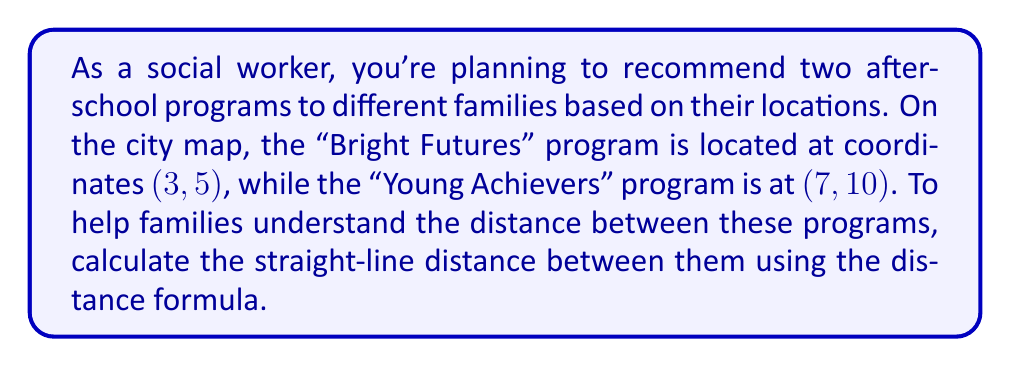Give your solution to this math problem. To solve this problem, we'll use the distance formula derived from the Pythagorean theorem. The distance formula for two points $(x_1, y_1)$ and $(x_2, y_2)$ is:

$$d = \sqrt{(x_2 - x_1)^2 + (y_2 - y_1)^2}$$

Let's identify our points:
- "Bright Futures": $(x_1, y_1) = (3, 5)$
- "Young Achievers": $(x_2, y_2) = (7, 10)$

Now, let's substitute these values into the formula:

$$\begin{align*}
d &= \sqrt{(7 - 3)^2 + (10 - 5)^2} \\
&= \sqrt{4^2 + 5^2} \\
&= \sqrt{16 + 25} \\
&= \sqrt{41} \\
&\approx 6.40 \text{ units}
\end{align*}$$

The unit of measurement depends on the scale of the city map. If the map uses a scale where 1 unit = 1 mile, then the distance would be approximately 6.40 miles.

[asy]
unitsize(1cm);
draw((-1,-1)--(9,12), gray);
dot((3,5));
dot((7,10));
label("Bright Futures (3,5)", (3,5), SW);
label("Young Achievers (7,10)", (7,10), NE);
draw((3,5)--(7,5)--(7,10), dashed);
label("4", (5,4.7), S);
label("5", (7.3,7.5), E);
label("$\sqrt{41}$", (5,7.5), NW);
[/asy]
Answer: The straight-line distance between the "Bright Futures" and "Young Achievers" afterschool programs is $\sqrt{41}$ units, or approximately 6.40 units on the city map. 